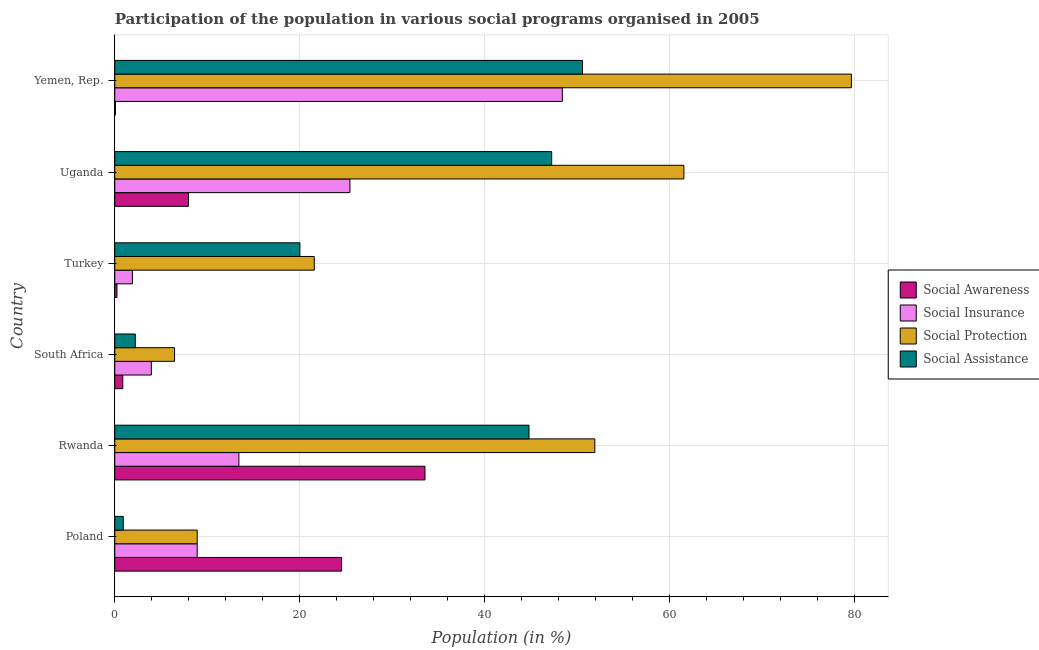How many different coloured bars are there?
Make the answer very short. 4. Are the number of bars per tick equal to the number of legend labels?
Your answer should be very brief. Yes. What is the label of the 5th group of bars from the top?
Make the answer very short. Rwanda. What is the participation of population in social protection programs in Yemen, Rep.?
Provide a succinct answer. 79.66. Across all countries, what is the maximum participation of population in social protection programs?
Offer a terse response. 79.66. Across all countries, what is the minimum participation of population in social insurance programs?
Offer a terse response. 1.91. In which country was the participation of population in social insurance programs maximum?
Offer a terse response. Yemen, Rep. In which country was the participation of population in social protection programs minimum?
Provide a succinct answer. South Africa. What is the total participation of population in social assistance programs in the graph?
Keep it short and to the point. 165.79. What is the difference between the participation of population in social insurance programs in Turkey and that in Uganda?
Keep it short and to the point. -23.52. What is the difference between the participation of population in social insurance programs in South Africa and the participation of population in social assistance programs in Poland?
Provide a succinct answer. 3.04. What is the average participation of population in social insurance programs per country?
Make the answer very short. 17. What is the difference between the participation of population in social insurance programs and participation of population in social awareness programs in Poland?
Give a very brief answer. -15.61. In how many countries, is the participation of population in social protection programs greater than 56 %?
Provide a succinct answer. 2. What is the ratio of the participation of population in social insurance programs in Turkey to that in Uganda?
Your answer should be compact. 0.07. Is the difference between the participation of population in social insurance programs in Poland and Yemen, Rep. greater than the difference between the participation of population in social protection programs in Poland and Yemen, Rep.?
Offer a very short reply. Yes. What is the difference between the highest and the second highest participation of population in social assistance programs?
Keep it short and to the point. 3.33. What is the difference between the highest and the lowest participation of population in social protection programs?
Provide a short and direct response. 73.19. Is it the case that in every country, the sum of the participation of population in social insurance programs and participation of population in social protection programs is greater than the sum of participation of population in social awareness programs and participation of population in social assistance programs?
Offer a very short reply. No. What does the 1st bar from the top in Uganda represents?
Offer a terse response. Social Assistance. What does the 1st bar from the bottom in South Africa represents?
Offer a terse response. Social Awareness. Are all the bars in the graph horizontal?
Offer a very short reply. Yes. Are the values on the major ticks of X-axis written in scientific E-notation?
Your answer should be very brief. No. Does the graph contain any zero values?
Your answer should be compact. No. Does the graph contain grids?
Offer a terse response. Yes. How are the legend labels stacked?
Your answer should be very brief. Vertical. What is the title of the graph?
Provide a short and direct response. Participation of the population in various social programs organised in 2005. What is the Population (in %) in Social Awareness in Poland?
Your answer should be compact. 24.53. What is the Population (in %) in Social Insurance in Poland?
Keep it short and to the point. 8.91. What is the Population (in %) in Social Protection in Poland?
Ensure brevity in your answer.  8.91. What is the Population (in %) in Social Assistance in Poland?
Make the answer very short. 0.92. What is the Population (in %) in Social Awareness in Rwanda?
Offer a terse response. 33.54. What is the Population (in %) of Social Insurance in Rwanda?
Keep it short and to the point. 13.42. What is the Population (in %) in Social Protection in Rwanda?
Give a very brief answer. 51.91. What is the Population (in %) of Social Assistance in Rwanda?
Your answer should be compact. 44.79. What is the Population (in %) in Social Awareness in South Africa?
Keep it short and to the point. 0.87. What is the Population (in %) in Social Insurance in South Africa?
Offer a terse response. 3.96. What is the Population (in %) of Social Protection in South Africa?
Provide a short and direct response. 6.47. What is the Population (in %) in Social Assistance in South Africa?
Give a very brief answer. 2.22. What is the Population (in %) of Social Awareness in Turkey?
Your answer should be compact. 0.24. What is the Population (in %) in Social Insurance in Turkey?
Keep it short and to the point. 1.91. What is the Population (in %) of Social Protection in Turkey?
Ensure brevity in your answer.  21.58. What is the Population (in %) in Social Assistance in Turkey?
Provide a short and direct response. 20.02. What is the Population (in %) of Social Awareness in Uganda?
Provide a short and direct response. 7.98. What is the Population (in %) of Social Insurance in Uganda?
Provide a succinct answer. 25.43. What is the Population (in %) of Social Protection in Uganda?
Offer a very short reply. 61.55. What is the Population (in %) in Social Assistance in Uganda?
Ensure brevity in your answer.  47.25. What is the Population (in %) in Social Awareness in Yemen, Rep.?
Provide a short and direct response. 0.07. What is the Population (in %) in Social Insurance in Yemen, Rep.?
Offer a terse response. 48.4. What is the Population (in %) of Social Protection in Yemen, Rep.?
Your response must be concise. 79.66. What is the Population (in %) in Social Assistance in Yemen, Rep.?
Make the answer very short. 50.58. Across all countries, what is the maximum Population (in %) of Social Awareness?
Ensure brevity in your answer.  33.54. Across all countries, what is the maximum Population (in %) in Social Insurance?
Offer a very short reply. 48.4. Across all countries, what is the maximum Population (in %) in Social Protection?
Give a very brief answer. 79.66. Across all countries, what is the maximum Population (in %) of Social Assistance?
Offer a very short reply. 50.58. Across all countries, what is the minimum Population (in %) of Social Awareness?
Your answer should be very brief. 0.07. Across all countries, what is the minimum Population (in %) of Social Insurance?
Provide a succinct answer. 1.91. Across all countries, what is the minimum Population (in %) in Social Protection?
Your response must be concise. 6.47. Across all countries, what is the minimum Population (in %) in Social Assistance?
Your response must be concise. 0.92. What is the total Population (in %) in Social Awareness in the graph?
Your answer should be compact. 67.22. What is the total Population (in %) of Social Insurance in the graph?
Make the answer very short. 102.03. What is the total Population (in %) in Social Protection in the graph?
Your response must be concise. 230.08. What is the total Population (in %) of Social Assistance in the graph?
Keep it short and to the point. 165.79. What is the difference between the Population (in %) in Social Awareness in Poland and that in Rwanda?
Provide a short and direct response. -9.02. What is the difference between the Population (in %) of Social Insurance in Poland and that in Rwanda?
Give a very brief answer. -4.51. What is the difference between the Population (in %) of Social Protection in Poland and that in Rwanda?
Ensure brevity in your answer.  -43. What is the difference between the Population (in %) in Social Assistance in Poland and that in Rwanda?
Your answer should be compact. -43.88. What is the difference between the Population (in %) in Social Awareness in Poland and that in South Africa?
Your answer should be very brief. 23.66. What is the difference between the Population (in %) in Social Insurance in Poland and that in South Africa?
Offer a very short reply. 4.96. What is the difference between the Population (in %) in Social Protection in Poland and that in South Africa?
Give a very brief answer. 2.45. What is the difference between the Population (in %) of Social Assistance in Poland and that in South Africa?
Ensure brevity in your answer.  -1.3. What is the difference between the Population (in %) of Social Awareness in Poland and that in Turkey?
Give a very brief answer. 24.29. What is the difference between the Population (in %) of Social Insurance in Poland and that in Turkey?
Your response must be concise. 7.01. What is the difference between the Population (in %) in Social Protection in Poland and that in Turkey?
Ensure brevity in your answer.  -12.66. What is the difference between the Population (in %) in Social Assistance in Poland and that in Turkey?
Provide a short and direct response. -19.11. What is the difference between the Population (in %) in Social Awareness in Poland and that in Uganda?
Provide a short and direct response. 16.55. What is the difference between the Population (in %) in Social Insurance in Poland and that in Uganda?
Make the answer very short. -16.51. What is the difference between the Population (in %) of Social Protection in Poland and that in Uganda?
Provide a short and direct response. -52.63. What is the difference between the Population (in %) of Social Assistance in Poland and that in Uganda?
Offer a terse response. -46.33. What is the difference between the Population (in %) of Social Awareness in Poland and that in Yemen, Rep.?
Provide a succinct answer. 24.46. What is the difference between the Population (in %) of Social Insurance in Poland and that in Yemen, Rep.?
Make the answer very short. -39.48. What is the difference between the Population (in %) in Social Protection in Poland and that in Yemen, Rep.?
Your answer should be compact. -70.74. What is the difference between the Population (in %) of Social Assistance in Poland and that in Yemen, Rep.?
Keep it short and to the point. -49.66. What is the difference between the Population (in %) in Social Awareness in Rwanda and that in South Africa?
Keep it short and to the point. 32.68. What is the difference between the Population (in %) in Social Insurance in Rwanda and that in South Africa?
Keep it short and to the point. 9.47. What is the difference between the Population (in %) of Social Protection in Rwanda and that in South Africa?
Your answer should be very brief. 45.45. What is the difference between the Population (in %) of Social Assistance in Rwanda and that in South Africa?
Offer a very short reply. 42.57. What is the difference between the Population (in %) of Social Awareness in Rwanda and that in Turkey?
Make the answer very short. 33.3. What is the difference between the Population (in %) in Social Insurance in Rwanda and that in Turkey?
Provide a short and direct response. 11.52. What is the difference between the Population (in %) of Social Protection in Rwanda and that in Turkey?
Provide a short and direct response. 30.34. What is the difference between the Population (in %) of Social Assistance in Rwanda and that in Turkey?
Provide a succinct answer. 24.77. What is the difference between the Population (in %) of Social Awareness in Rwanda and that in Uganda?
Provide a short and direct response. 25.57. What is the difference between the Population (in %) of Social Insurance in Rwanda and that in Uganda?
Keep it short and to the point. -12.01. What is the difference between the Population (in %) in Social Protection in Rwanda and that in Uganda?
Your answer should be very brief. -9.63. What is the difference between the Population (in %) in Social Assistance in Rwanda and that in Uganda?
Provide a succinct answer. -2.45. What is the difference between the Population (in %) of Social Awareness in Rwanda and that in Yemen, Rep.?
Ensure brevity in your answer.  33.48. What is the difference between the Population (in %) in Social Insurance in Rwanda and that in Yemen, Rep.?
Provide a short and direct response. -34.97. What is the difference between the Population (in %) in Social Protection in Rwanda and that in Yemen, Rep.?
Offer a terse response. -27.75. What is the difference between the Population (in %) of Social Assistance in Rwanda and that in Yemen, Rep.?
Make the answer very short. -5.79. What is the difference between the Population (in %) of Social Awareness in South Africa and that in Turkey?
Your answer should be very brief. 0.63. What is the difference between the Population (in %) in Social Insurance in South Africa and that in Turkey?
Your answer should be compact. 2.05. What is the difference between the Population (in %) of Social Protection in South Africa and that in Turkey?
Your response must be concise. -15.11. What is the difference between the Population (in %) in Social Assistance in South Africa and that in Turkey?
Provide a short and direct response. -17.8. What is the difference between the Population (in %) in Social Awareness in South Africa and that in Uganda?
Offer a terse response. -7.11. What is the difference between the Population (in %) of Social Insurance in South Africa and that in Uganda?
Offer a very short reply. -21.47. What is the difference between the Population (in %) of Social Protection in South Africa and that in Uganda?
Keep it short and to the point. -55.08. What is the difference between the Population (in %) of Social Assistance in South Africa and that in Uganda?
Your answer should be very brief. -45.03. What is the difference between the Population (in %) of Social Awareness in South Africa and that in Yemen, Rep.?
Offer a very short reply. 0.8. What is the difference between the Population (in %) in Social Insurance in South Africa and that in Yemen, Rep.?
Keep it short and to the point. -44.44. What is the difference between the Population (in %) of Social Protection in South Africa and that in Yemen, Rep.?
Provide a succinct answer. -73.19. What is the difference between the Population (in %) of Social Assistance in South Africa and that in Yemen, Rep.?
Provide a succinct answer. -48.36. What is the difference between the Population (in %) of Social Awareness in Turkey and that in Uganda?
Make the answer very short. -7.74. What is the difference between the Population (in %) of Social Insurance in Turkey and that in Uganda?
Provide a short and direct response. -23.52. What is the difference between the Population (in %) of Social Protection in Turkey and that in Uganda?
Give a very brief answer. -39.97. What is the difference between the Population (in %) of Social Assistance in Turkey and that in Uganda?
Your answer should be very brief. -27.22. What is the difference between the Population (in %) of Social Awareness in Turkey and that in Yemen, Rep.?
Give a very brief answer. 0.17. What is the difference between the Population (in %) in Social Insurance in Turkey and that in Yemen, Rep.?
Your response must be concise. -46.49. What is the difference between the Population (in %) in Social Protection in Turkey and that in Yemen, Rep.?
Provide a short and direct response. -58.08. What is the difference between the Population (in %) in Social Assistance in Turkey and that in Yemen, Rep.?
Offer a very short reply. -30.56. What is the difference between the Population (in %) in Social Awareness in Uganda and that in Yemen, Rep.?
Keep it short and to the point. 7.91. What is the difference between the Population (in %) of Social Insurance in Uganda and that in Yemen, Rep.?
Provide a short and direct response. -22.97. What is the difference between the Population (in %) in Social Protection in Uganda and that in Yemen, Rep.?
Provide a short and direct response. -18.11. What is the difference between the Population (in %) of Social Assistance in Uganda and that in Yemen, Rep.?
Make the answer very short. -3.34. What is the difference between the Population (in %) of Social Awareness in Poland and the Population (in %) of Social Insurance in Rwanda?
Keep it short and to the point. 11.1. What is the difference between the Population (in %) of Social Awareness in Poland and the Population (in %) of Social Protection in Rwanda?
Offer a very short reply. -27.39. What is the difference between the Population (in %) in Social Awareness in Poland and the Population (in %) in Social Assistance in Rwanda?
Your answer should be compact. -20.27. What is the difference between the Population (in %) of Social Insurance in Poland and the Population (in %) of Social Protection in Rwanda?
Ensure brevity in your answer.  -43. What is the difference between the Population (in %) in Social Insurance in Poland and the Population (in %) in Social Assistance in Rwanda?
Your answer should be very brief. -35.88. What is the difference between the Population (in %) in Social Protection in Poland and the Population (in %) in Social Assistance in Rwanda?
Offer a terse response. -35.88. What is the difference between the Population (in %) of Social Awareness in Poland and the Population (in %) of Social Insurance in South Africa?
Keep it short and to the point. 20.57. What is the difference between the Population (in %) in Social Awareness in Poland and the Population (in %) in Social Protection in South Africa?
Provide a succinct answer. 18.06. What is the difference between the Population (in %) of Social Awareness in Poland and the Population (in %) of Social Assistance in South Africa?
Make the answer very short. 22.31. What is the difference between the Population (in %) of Social Insurance in Poland and the Population (in %) of Social Protection in South Africa?
Keep it short and to the point. 2.45. What is the difference between the Population (in %) of Social Insurance in Poland and the Population (in %) of Social Assistance in South Africa?
Offer a terse response. 6.69. What is the difference between the Population (in %) in Social Protection in Poland and the Population (in %) in Social Assistance in South Africa?
Offer a terse response. 6.69. What is the difference between the Population (in %) of Social Awareness in Poland and the Population (in %) of Social Insurance in Turkey?
Your answer should be very brief. 22.62. What is the difference between the Population (in %) in Social Awareness in Poland and the Population (in %) in Social Protection in Turkey?
Offer a terse response. 2.95. What is the difference between the Population (in %) in Social Awareness in Poland and the Population (in %) in Social Assistance in Turkey?
Offer a very short reply. 4.5. What is the difference between the Population (in %) in Social Insurance in Poland and the Population (in %) in Social Protection in Turkey?
Make the answer very short. -12.66. What is the difference between the Population (in %) in Social Insurance in Poland and the Population (in %) in Social Assistance in Turkey?
Your answer should be very brief. -11.11. What is the difference between the Population (in %) of Social Protection in Poland and the Population (in %) of Social Assistance in Turkey?
Your answer should be very brief. -11.11. What is the difference between the Population (in %) in Social Awareness in Poland and the Population (in %) in Social Insurance in Uganda?
Your response must be concise. -0.9. What is the difference between the Population (in %) in Social Awareness in Poland and the Population (in %) in Social Protection in Uganda?
Offer a terse response. -37.02. What is the difference between the Population (in %) of Social Awareness in Poland and the Population (in %) of Social Assistance in Uganda?
Give a very brief answer. -22.72. What is the difference between the Population (in %) in Social Insurance in Poland and the Population (in %) in Social Protection in Uganda?
Ensure brevity in your answer.  -52.63. What is the difference between the Population (in %) in Social Insurance in Poland and the Population (in %) in Social Assistance in Uganda?
Keep it short and to the point. -38.33. What is the difference between the Population (in %) of Social Protection in Poland and the Population (in %) of Social Assistance in Uganda?
Ensure brevity in your answer.  -38.33. What is the difference between the Population (in %) of Social Awareness in Poland and the Population (in %) of Social Insurance in Yemen, Rep.?
Give a very brief answer. -23.87. What is the difference between the Population (in %) of Social Awareness in Poland and the Population (in %) of Social Protection in Yemen, Rep.?
Your answer should be compact. -55.13. What is the difference between the Population (in %) of Social Awareness in Poland and the Population (in %) of Social Assistance in Yemen, Rep.?
Provide a short and direct response. -26.06. What is the difference between the Population (in %) in Social Insurance in Poland and the Population (in %) in Social Protection in Yemen, Rep.?
Your answer should be very brief. -70.74. What is the difference between the Population (in %) in Social Insurance in Poland and the Population (in %) in Social Assistance in Yemen, Rep.?
Give a very brief answer. -41.67. What is the difference between the Population (in %) of Social Protection in Poland and the Population (in %) of Social Assistance in Yemen, Rep.?
Provide a succinct answer. -41.67. What is the difference between the Population (in %) in Social Awareness in Rwanda and the Population (in %) in Social Insurance in South Africa?
Provide a short and direct response. 29.59. What is the difference between the Population (in %) in Social Awareness in Rwanda and the Population (in %) in Social Protection in South Africa?
Ensure brevity in your answer.  27.07. What is the difference between the Population (in %) in Social Awareness in Rwanda and the Population (in %) in Social Assistance in South Africa?
Give a very brief answer. 31.32. What is the difference between the Population (in %) in Social Insurance in Rwanda and the Population (in %) in Social Protection in South Africa?
Your response must be concise. 6.96. What is the difference between the Population (in %) of Social Insurance in Rwanda and the Population (in %) of Social Assistance in South Africa?
Give a very brief answer. 11.2. What is the difference between the Population (in %) of Social Protection in Rwanda and the Population (in %) of Social Assistance in South Africa?
Provide a short and direct response. 49.69. What is the difference between the Population (in %) of Social Awareness in Rwanda and the Population (in %) of Social Insurance in Turkey?
Keep it short and to the point. 31.64. What is the difference between the Population (in %) of Social Awareness in Rwanda and the Population (in %) of Social Protection in Turkey?
Keep it short and to the point. 11.96. What is the difference between the Population (in %) of Social Awareness in Rwanda and the Population (in %) of Social Assistance in Turkey?
Give a very brief answer. 13.52. What is the difference between the Population (in %) in Social Insurance in Rwanda and the Population (in %) in Social Protection in Turkey?
Provide a short and direct response. -8.15. What is the difference between the Population (in %) in Social Insurance in Rwanda and the Population (in %) in Social Assistance in Turkey?
Your answer should be compact. -6.6. What is the difference between the Population (in %) in Social Protection in Rwanda and the Population (in %) in Social Assistance in Turkey?
Your answer should be compact. 31.89. What is the difference between the Population (in %) in Social Awareness in Rwanda and the Population (in %) in Social Insurance in Uganda?
Provide a succinct answer. 8.11. What is the difference between the Population (in %) of Social Awareness in Rwanda and the Population (in %) of Social Protection in Uganda?
Your answer should be compact. -28. What is the difference between the Population (in %) in Social Awareness in Rwanda and the Population (in %) in Social Assistance in Uganda?
Ensure brevity in your answer.  -13.71. What is the difference between the Population (in %) in Social Insurance in Rwanda and the Population (in %) in Social Protection in Uganda?
Provide a short and direct response. -48.12. What is the difference between the Population (in %) of Social Insurance in Rwanda and the Population (in %) of Social Assistance in Uganda?
Your answer should be compact. -33.82. What is the difference between the Population (in %) in Social Protection in Rwanda and the Population (in %) in Social Assistance in Uganda?
Your answer should be very brief. 4.67. What is the difference between the Population (in %) in Social Awareness in Rwanda and the Population (in %) in Social Insurance in Yemen, Rep.?
Offer a very short reply. -14.86. What is the difference between the Population (in %) in Social Awareness in Rwanda and the Population (in %) in Social Protection in Yemen, Rep.?
Give a very brief answer. -46.12. What is the difference between the Population (in %) in Social Awareness in Rwanda and the Population (in %) in Social Assistance in Yemen, Rep.?
Your answer should be compact. -17.04. What is the difference between the Population (in %) in Social Insurance in Rwanda and the Population (in %) in Social Protection in Yemen, Rep.?
Offer a very short reply. -66.23. What is the difference between the Population (in %) in Social Insurance in Rwanda and the Population (in %) in Social Assistance in Yemen, Rep.?
Provide a short and direct response. -37.16. What is the difference between the Population (in %) in Social Protection in Rwanda and the Population (in %) in Social Assistance in Yemen, Rep.?
Make the answer very short. 1.33. What is the difference between the Population (in %) in Social Awareness in South Africa and the Population (in %) in Social Insurance in Turkey?
Keep it short and to the point. -1.04. What is the difference between the Population (in %) of Social Awareness in South Africa and the Population (in %) of Social Protection in Turkey?
Ensure brevity in your answer.  -20.71. What is the difference between the Population (in %) of Social Awareness in South Africa and the Population (in %) of Social Assistance in Turkey?
Make the answer very short. -19.16. What is the difference between the Population (in %) of Social Insurance in South Africa and the Population (in %) of Social Protection in Turkey?
Provide a short and direct response. -17.62. What is the difference between the Population (in %) of Social Insurance in South Africa and the Population (in %) of Social Assistance in Turkey?
Offer a terse response. -16.07. What is the difference between the Population (in %) of Social Protection in South Africa and the Population (in %) of Social Assistance in Turkey?
Keep it short and to the point. -13.56. What is the difference between the Population (in %) of Social Awareness in South Africa and the Population (in %) of Social Insurance in Uganda?
Your answer should be compact. -24.56. What is the difference between the Population (in %) of Social Awareness in South Africa and the Population (in %) of Social Protection in Uganda?
Your answer should be compact. -60.68. What is the difference between the Population (in %) in Social Awareness in South Africa and the Population (in %) in Social Assistance in Uganda?
Your answer should be very brief. -46.38. What is the difference between the Population (in %) in Social Insurance in South Africa and the Population (in %) in Social Protection in Uganda?
Your answer should be compact. -57.59. What is the difference between the Population (in %) in Social Insurance in South Africa and the Population (in %) in Social Assistance in Uganda?
Provide a succinct answer. -43.29. What is the difference between the Population (in %) in Social Protection in South Africa and the Population (in %) in Social Assistance in Uganda?
Your response must be concise. -40.78. What is the difference between the Population (in %) in Social Awareness in South Africa and the Population (in %) in Social Insurance in Yemen, Rep.?
Offer a very short reply. -47.53. What is the difference between the Population (in %) in Social Awareness in South Africa and the Population (in %) in Social Protection in Yemen, Rep.?
Ensure brevity in your answer.  -78.79. What is the difference between the Population (in %) of Social Awareness in South Africa and the Population (in %) of Social Assistance in Yemen, Rep.?
Ensure brevity in your answer.  -49.72. What is the difference between the Population (in %) in Social Insurance in South Africa and the Population (in %) in Social Protection in Yemen, Rep.?
Your answer should be compact. -75.7. What is the difference between the Population (in %) in Social Insurance in South Africa and the Population (in %) in Social Assistance in Yemen, Rep.?
Your answer should be very brief. -46.63. What is the difference between the Population (in %) in Social Protection in South Africa and the Population (in %) in Social Assistance in Yemen, Rep.?
Keep it short and to the point. -44.12. What is the difference between the Population (in %) of Social Awareness in Turkey and the Population (in %) of Social Insurance in Uganda?
Keep it short and to the point. -25.19. What is the difference between the Population (in %) of Social Awareness in Turkey and the Population (in %) of Social Protection in Uganda?
Keep it short and to the point. -61.31. What is the difference between the Population (in %) of Social Awareness in Turkey and the Population (in %) of Social Assistance in Uganda?
Provide a short and direct response. -47.01. What is the difference between the Population (in %) of Social Insurance in Turkey and the Population (in %) of Social Protection in Uganda?
Your answer should be very brief. -59.64. What is the difference between the Population (in %) in Social Insurance in Turkey and the Population (in %) in Social Assistance in Uganda?
Provide a short and direct response. -45.34. What is the difference between the Population (in %) in Social Protection in Turkey and the Population (in %) in Social Assistance in Uganda?
Give a very brief answer. -25.67. What is the difference between the Population (in %) of Social Awareness in Turkey and the Population (in %) of Social Insurance in Yemen, Rep.?
Make the answer very short. -48.16. What is the difference between the Population (in %) in Social Awareness in Turkey and the Population (in %) in Social Protection in Yemen, Rep.?
Make the answer very short. -79.42. What is the difference between the Population (in %) in Social Awareness in Turkey and the Population (in %) in Social Assistance in Yemen, Rep.?
Provide a short and direct response. -50.34. What is the difference between the Population (in %) of Social Insurance in Turkey and the Population (in %) of Social Protection in Yemen, Rep.?
Ensure brevity in your answer.  -77.75. What is the difference between the Population (in %) in Social Insurance in Turkey and the Population (in %) in Social Assistance in Yemen, Rep.?
Provide a short and direct response. -48.68. What is the difference between the Population (in %) in Social Protection in Turkey and the Population (in %) in Social Assistance in Yemen, Rep.?
Ensure brevity in your answer.  -29. What is the difference between the Population (in %) of Social Awareness in Uganda and the Population (in %) of Social Insurance in Yemen, Rep.?
Keep it short and to the point. -40.42. What is the difference between the Population (in %) of Social Awareness in Uganda and the Population (in %) of Social Protection in Yemen, Rep.?
Provide a short and direct response. -71.68. What is the difference between the Population (in %) in Social Awareness in Uganda and the Population (in %) in Social Assistance in Yemen, Rep.?
Offer a very short reply. -42.61. What is the difference between the Population (in %) of Social Insurance in Uganda and the Population (in %) of Social Protection in Yemen, Rep.?
Provide a succinct answer. -54.23. What is the difference between the Population (in %) of Social Insurance in Uganda and the Population (in %) of Social Assistance in Yemen, Rep.?
Ensure brevity in your answer.  -25.15. What is the difference between the Population (in %) in Social Protection in Uganda and the Population (in %) in Social Assistance in Yemen, Rep.?
Make the answer very short. 10.96. What is the average Population (in %) in Social Awareness per country?
Make the answer very short. 11.2. What is the average Population (in %) in Social Insurance per country?
Give a very brief answer. 17.01. What is the average Population (in %) in Social Protection per country?
Your answer should be very brief. 38.35. What is the average Population (in %) of Social Assistance per country?
Your answer should be very brief. 27.63. What is the difference between the Population (in %) in Social Awareness and Population (in %) in Social Insurance in Poland?
Offer a terse response. 15.61. What is the difference between the Population (in %) in Social Awareness and Population (in %) in Social Protection in Poland?
Offer a very short reply. 15.61. What is the difference between the Population (in %) in Social Awareness and Population (in %) in Social Assistance in Poland?
Your response must be concise. 23.61. What is the difference between the Population (in %) of Social Insurance and Population (in %) of Social Protection in Poland?
Your answer should be compact. 0. What is the difference between the Population (in %) in Social Insurance and Population (in %) in Social Assistance in Poland?
Keep it short and to the point. 8. What is the difference between the Population (in %) of Social Protection and Population (in %) of Social Assistance in Poland?
Your answer should be very brief. 8. What is the difference between the Population (in %) in Social Awareness and Population (in %) in Social Insurance in Rwanda?
Your answer should be compact. 20.12. What is the difference between the Population (in %) in Social Awareness and Population (in %) in Social Protection in Rwanda?
Keep it short and to the point. -18.37. What is the difference between the Population (in %) of Social Awareness and Population (in %) of Social Assistance in Rwanda?
Offer a very short reply. -11.25. What is the difference between the Population (in %) in Social Insurance and Population (in %) in Social Protection in Rwanda?
Your response must be concise. -38.49. What is the difference between the Population (in %) of Social Insurance and Population (in %) of Social Assistance in Rwanda?
Ensure brevity in your answer.  -31.37. What is the difference between the Population (in %) in Social Protection and Population (in %) in Social Assistance in Rwanda?
Ensure brevity in your answer.  7.12. What is the difference between the Population (in %) of Social Awareness and Population (in %) of Social Insurance in South Africa?
Your answer should be compact. -3.09. What is the difference between the Population (in %) of Social Awareness and Population (in %) of Social Protection in South Africa?
Your response must be concise. -5.6. What is the difference between the Population (in %) of Social Awareness and Population (in %) of Social Assistance in South Africa?
Your response must be concise. -1.35. What is the difference between the Population (in %) of Social Insurance and Population (in %) of Social Protection in South Africa?
Offer a terse response. -2.51. What is the difference between the Population (in %) of Social Insurance and Population (in %) of Social Assistance in South Africa?
Provide a short and direct response. 1.74. What is the difference between the Population (in %) of Social Protection and Population (in %) of Social Assistance in South Africa?
Provide a succinct answer. 4.25. What is the difference between the Population (in %) of Social Awareness and Population (in %) of Social Insurance in Turkey?
Your response must be concise. -1.67. What is the difference between the Population (in %) in Social Awareness and Population (in %) in Social Protection in Turkey?
Provide a succinct answer. -21.34. What is the difference between the Population (in %) in Social Awareness and Population (in %) in Social Assistance in Turkey?
Your response must be concise. -19.79. What is the difference between the Population (in %) of Social Insurance and Population (in %) of Social Protection in Turkey?
Offer a very short reply. -19.67. What is the difference between the Population (in %) in Social Insurance and Population (in %) in Social Assistance in Turkey?
Make the answer very short. -18.12. What is the difference between the Population (in %) in Social Protection and Population (in %) in Social Assistance in Turkey?
Offer a terse response. 1.55. What is the difference between the Population (in %) of Social Awareness and Population (in %) of Social Insurance in Uganda?
Provide a succinct answer. -17.45. What is the difference between the Population (in %) of Social Awareness and Population (in %) of Social Protection in Uganda?
Make the answer very short. -53.57. What is the difference between the Population (in %) in Social Awareness and Population (in %) in Social Assistance in Uganda?
Give a very brief answer. -39.27. What is the difference between the Population (in %) of Social Insurance and Population (in %) of Social Protection in Uganda?
Provide a succinct answer. -36.12. What is the difference between the Population (in %) in Social Insurance and Population (in %) in Social Assistance in Uganda?
Offer a terse response. -21.82. What is the difference between the Population (in %) of Social Protection and Population (in %) of Social Assistance in Uganda?
Give a very brief answer. 14.3. What is the difference between the Population (in %) in Social Awareness and Population (in %) in Social Insurance in Yemen, Rep.?
Offer a very short reply. -48.33. What is the difference between the Population (in %) of Social Awareness and Population (in %) of Social Protection in Yemen, Rep.?
Your response must be concise. -79.59. What is the difference between the Population (in %) of Social Awareness and Population (in %) of Social Assistance in Yemen, Rep.?
Keep it short and to the point. -50.52. What is the difference between the Population (in %) of Social Insurance and Population (in %) of Social Protection in Yemen, Rep.?
Provide a short and direct response. -31.26. What is the difference between the Population (in %) in Social Insurance and Population (in %) in Social Assistance in Yemen, Rep.?
Keep it short and to the point. -2.18. What is the difference between the Population (in %) of Social Protection and Population (in %) of Social Assistance in Yemen, Rep.?
Keep it short and to the point. 29.08. What is the ratio of the Population (in %) in Social Awareness in Poland to that in Rwanda?
Make the answer very short. 0.73. What is the ratio of the Population (in %) in Social Insurance in Poland to that in Rwanda?
Keep it short and to the point. 0.66. What is the ratio of the Population (in %) in Social Protection in Poland to that in Rwanda?
Keep it short and to the point. 0.17. What is the ratio of the Population (in %) of Social Assistance in Poland to that in Rwanda?
Provide a succinct answer. 0.02. What is the ratio of the Population (in %) of Social Awareness in Poland to that in South Africa?
Give a very brief answer. 28.28. What is the ratio of the Population (in %) in Social Insurance in Poland to that in South Africa?
Keep it short and to the point. 2.25. What is the ratio of the Population (in %) in Social Protection in Poland to that in South Africa?
Give a very brief answer. 1.38. What is the ratio of the Population (in %) in Social Assistance in Poland to that in South Africa?
Provide a short and direct response. 0.41. What is the ratio of the Population (in %) in Social Awareness in Poland to that in Turkey?
Offer a very short reply. 102.92. What is the ratio of the Population (in %) of Social Insurance in Poland to that in Turkey?
Make the answer very short. 4.67. What is the ratio of the Population (in %) in Social Protection in Poland to that in Turkey?
Your answer should be compact. 0.41. What is the ratio of the Population (in %) of Social Assistance in Poland to that in Turkey?
Your answer should be compact. 0.05. What is the ratio of the Population (in %) in Social Awareness in Poland to that in Uganda?
Provide a short and direct response. 3.07. What is the ratio of the Population (in %) of Social Insurance in Poland to that in Uganda?
Provide a succinct answer. 0.35. What is the ratio of the Population (in %) in Social Protection in Poland to that in Uganda?
Ensure brevity in your answer.  0.14. What is the ratio of the Population (in %) in Social Assistance in Poland to that in Uganda?
Offer a terse response. 0.02. What is the ratio of the Population (in %) of Social Awareness in Poland to that in Yemen, Rep.?
Your response must be concise. 371.26. What is the ratio of the Population (in %) in Social Insurance in Poland to that in Yemen, Rep.?
Keep it short and to the point. 0.18. What is the ratio of the Population (in %) of Social Protection in Poland to that in Yemen, Rep.?
Your answer should be very brief. 0.11. What is the ratio of the Population (in %) of Social Assistance in Poland to that in Yemen, Rep.?
Offer a very short reply. 0.02. What is the ratio of the Population (in %) in Social Awareness in Rwanda to that in South Africa?
Provide a succinct answer. 38.67. What is the ratio of the Population (in %) in Social Insurance in Rwanda to that in South Africa?
Offer a very short reply. 3.39. What is the ratio of the Population (in %) of Social Protection in Rwanda to that in South Africa?
Provide a succinct answer. 8.03. What is the ratio of the Population (in %) in Social Assistance in Rwanda to that in South Africa?
Your answer should be very brief. 20.17. What is the ratio of the Population (in %) of Social Awareness in Rwanda to that in Turkey?
Give a very brief answer. 140.75. What is the ratio of the Population (in %) of Social Insurance in Rwanda to that in Turkey?
Make the answer very short. 7.04. What is the ratio of the Population (in %) in Social Protection in Rwanda to that in Turkey?
Your answer should be very brief. 2.41. What is the ratio of the Population (in %) in Social Assistance in Rwanda to that in Turkey?
Keep it short and to the point. 2.24. What is the ratio of the Population (in %) of Social Awareness in Rwanda to that in Uganda?
Give a very brief answer. 4.21. What is the ratio of the Population (in %) in Social Insurance in Rwanda to that in Uganda?
Your answer should be compact. 0.53. What is the ratio of the Population (in %) of Social Protection in Rwanda to that in Uganda?
Offer a very short reply. 0.84. What is the ratio of the Population (in %) in Social Assistance in Rwanda to that in Uganda?
Offer a very short reply. 0.95. What is the ratio of the Population (in %) in Social Awareness in Rwanda to that in Yemen, Rep.?
Keep it short and to the point. 507.72. What is the ratio of the Population (in %) of Social Insurance in Rwanda to that in Yemen, Rep.?
Keep it short and to the point. 0.28. What is the ratio of the Population (in %) of Social Protection in Rwanda to that in Yemen, Rep.?
Offer a very short reply. 0.65. What is the ratio of the Population (in %) in Social Assistance in Rwanda to that in Yemen, Rep.?
Keep it short and to the point. 0.89. What is the ratio of the Population (in %) in Social Awareness in South Africa to that in Turkey?
Provide a succinct answer. 3.64. What is the ratio of the Population (in %) of Social Insurance in South Africa to that in Turkey?
Keep it short and to the point. 2.07. What is the ratio of the Population (in %) in Social Protection in South Africa to that in Turkey?
Your response must be concise. 0.3. What is the ratio of the Population (in %) in Social Assistance in South Africa to that in Turkey?
Your response must be concise. 0.11. What is the ratio of the Population (in %) in Social Awareness in South Africa to that in Uganda?
Your answer should be very brief. 0.11. What is the ratio of the Population (in %) of Social Insurance in South Africa to that in Uganda?
Make the answer very short. 0.16. What is the ratio of the Population (in %) in Social Protection in South Africa to that in Uganda?
Ensure brevity in your answer.  0.11. What is the ratio of the Population (in %) of Social Assistance in South Africa to that in Uganda?
Your answer should be compact. 0.05. What is the ratio of the Population (in %) of Social Awareness in South Africa to that in Yemen, Rep.?
Keep it short and to the point. 13.13. What is the ratio of the Population (in %) of Social Insurance in South Africa to that in Yemen, Rep.?
Make the answer very short. 0.08. What is the ratio of the Population (in %) of Social Protection in South Africa to that in Yemen, Rep.?
Offer a very short reply. 0.08. What is the ratio of the Population (in %) of Social Assistance in South Africa to that in Yemen, Rep.?
Your response must be concise. 0.04. What is the ratio of the Population (in %) of Social Awareness in Turkey to that in Uganda?
Give a very brief answer. 0.03. What is the ratio of the Population (in %) of Social Insurance in Turkey to that in Uganda?
Offer a terse response. 0.07. What is the ratio of the Population (in %) of Social Protection in Turkey to that in Uganda?
Give a very brief answer. 0.35. What is the ratio of the Population (in %) of Social Assistance in Turkey to that in Uganda?
Make the answer very short. 0.42. What is the ratio of the Population (in %) in Social Awareness in Turkey to that in Yemen, Rep.?
Your answer should be compact. 3.61. What is the ratio of the Population (in %) of Social Insurance in Turkey to that in Yemen, Rep.?
Your answer should be compact. 0.04. What is the ratio of the Population (in %) in Social Protection in Turkey to that in Yemen, Rep.?
Your answer should be compact. 0.27. What is the ratio of the Population (in %) of Social Assistance in Turkey to that in Yemen, Rep.?
Offer a terse response. 0.4. What is the ratio of the Population (in %) in Social Awareness in Uganda to that in Yemen, Rep.?
Keep it short and to the point. 120.74. What is the ratio of the Population (in %) in Social Insurance in Uganda to that in Yemen, Rep.?
Provide a succinct answer. 0.53. What is the ratio of the Population (in %) of Social Protection in Uganda to that in Yemen, Rep.?
Your response must be concise. 0.77. What is the ratio of the Population (in %) of Social Assistance in Uganda to that in Yemen, Rep.?
Provide a short and direct response. 0.93. What is the difference between the highest and the second highest Population (in %) in Social Awareness?
Offer a very short reply. 9.02. What is the difference between the highest and the second highest Population (in %) of Social Insurance?
Your answer should be very brief. 22.97. What is the difference between the highest and the second highest Population (in %) of Social Protection?
Make the answer very short. 18.11. What is the difference between the highest and the second highest Population (in %) of Social Assistance?
Offer a very short reply. 3.34. What is the difference between the highest and the lowest Population (in %) of Social Awareness?
Keep it short and to the point. 33.48. What is the difference between the highest and the lowest Population (in %) of Social Insurance?
Offer a terse response. 46.49. What is the difference between the highest and the lowest Population (in %) in Social Protection?
Your answer should be compact. 73.19. What is the difference between the highest and the lowest Population (in %) in Social Assistance?
Keep it short and to the point. 49.66. 